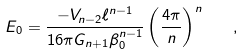<formula> <loc_0><loc_0><loc_500><loc_500>E _ { 0 } = \frac { - V _ { n - 2 } \ell ^ { n - 1 } } { 1 6 \pi G _ { n + 1 } \beta _ { 0 } ^ { n - 1 } } \left ( \frac { 4 \pi } { n } \right ) ^ { n } \quad ,</formula> 